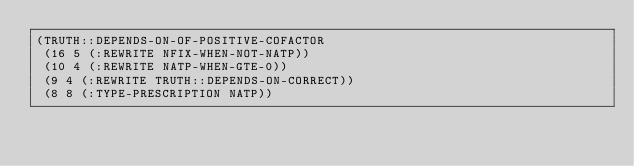<code> <loc_0><loc_0><loc_500><loc_500><_Lisp_>(TRUTH::DEPENDS-ON-OF-POSITIVE-COFACTOR
 (16 5 (:REWRITE NFIX-WHEN-NOT-NATP))
 (10 4 (:REWRITE NATP-WHEN-GTE-0))
 (9 4 (:REWRITE TRUTH::DEPENDS-ON-CORRECT))
 (8 8 (:TYPE-PRESCRIPTION NATP))</code> 